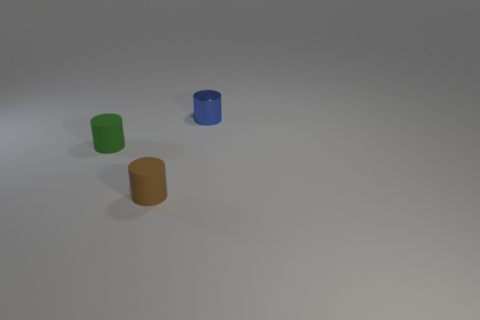Is there any other thing that has the same material as the small blue cylinder?
Your answer should be very brief. No. The cylinder that is both behind the brown rubber cylinder and right of the tiny green thing is made of what material?
Provide a short and direct response. Metal. What number of other small green objects are the same shape as the tiny metal thing?
Offer a terse response. 1. There is a matte cylinder in front of the small object that is on the left side of the small brown thing; how big is it?
Your response must be concise. Small. How many blue objects are right of the small brown cylinder in front of the object on the left side of the brown thing?
Provide a short and direct response. 1. What number of small objects are in front of the green object and behind the brown rubber cylinder?
Ensure brevity in your answer.  0. Are there more cylinders to the right of the green matte thing than tiny blue shiny cylinders?
Your answer should be compact. Yes. How many cylinders have the same size as the metal object?
Provide a short and direct response. 2. How many big things are either blue cylinders or green matte things?
Keep it short and to the point. 0. What number of big cyan metallic spheres are there?
Make the answer very short. 0. 